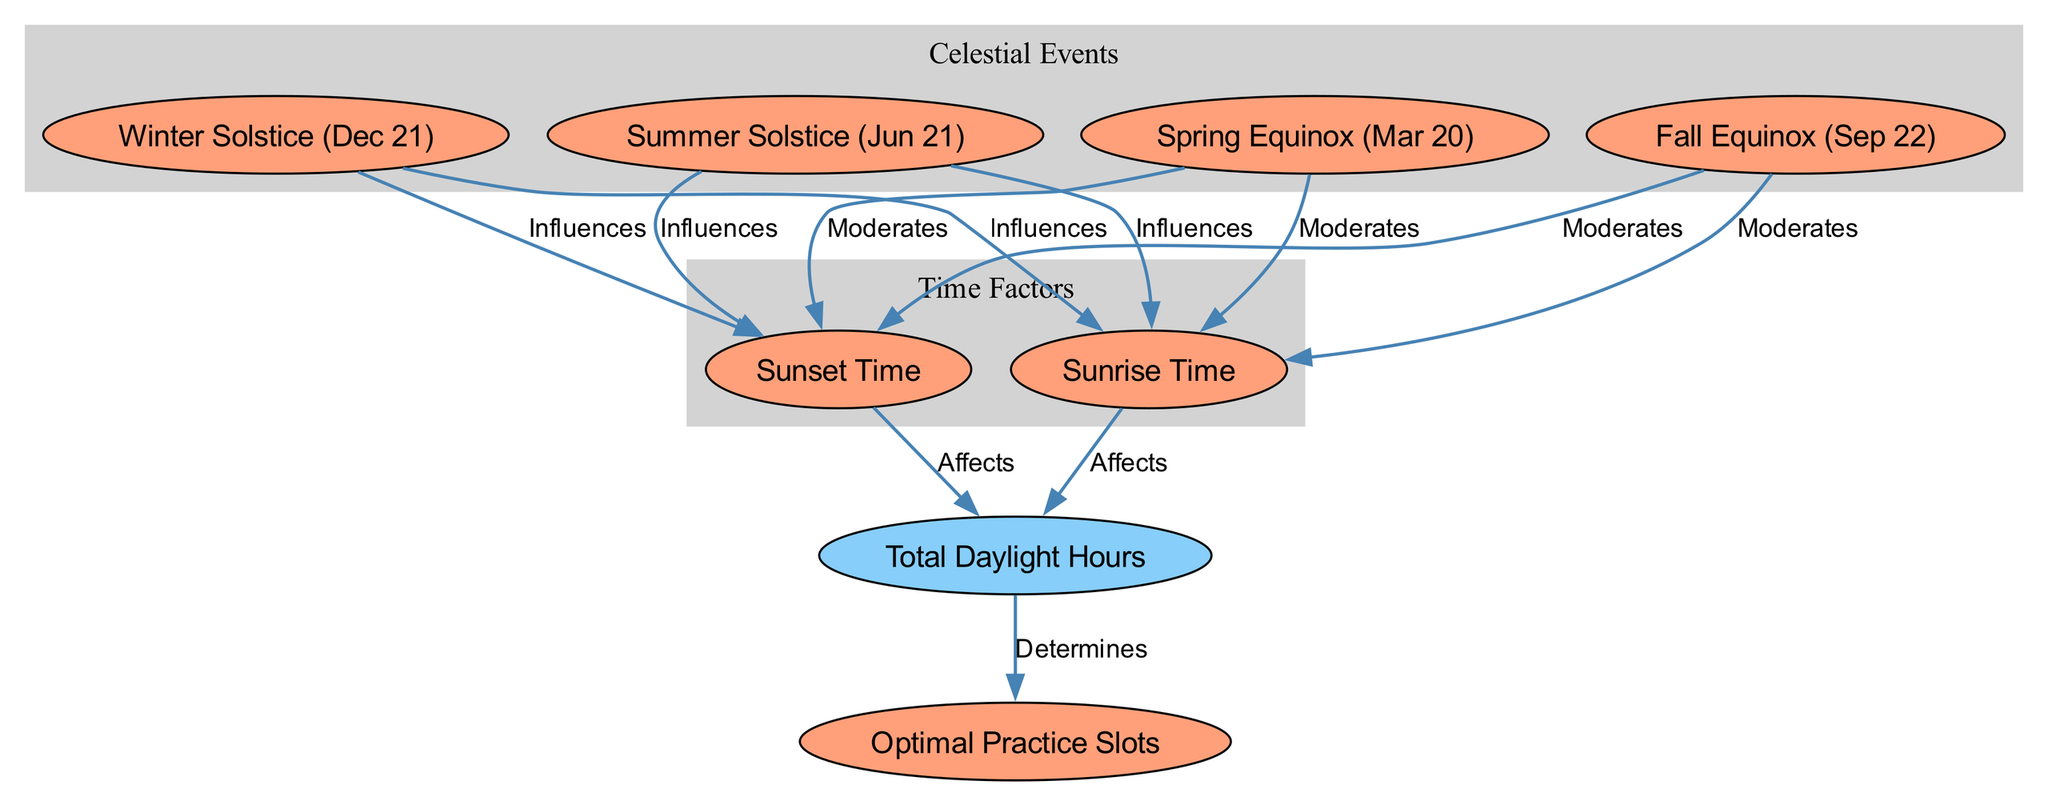What is the relationship between sunrise and daylight hours? Sunrise affects the total daylight hours according to the directed edge labeled "Affects" that connects "sunrise" to "daylightHours". This means that as the sunrise time changes, it directly influences how many daylight hours there are in a day.
Answer: Affects How many optimal practice slots are determined by daylight hours? The "Optimal Practice Slots" node is directly connected to the "Total Daylight Hours" node through an edge labeled "Determines". This indicates that the number of practice slots available is directly linked to the total hours of daylight.
Answer: Determines What season influences both sunrise and sunset times the most? The seasons that have a direct influence on both sunrise and sunset are represented by the "Winter Solstice" and "Summer Solstice". The connections labeled "Influences" indicate that these solstices impact both sunrise and sunset times.
Answer: Winter Solstice, Summer Solstice Which equinox moderates sunrise? The "Spring Equinox" and "Fall Equinox" both moderate sunrise as indicated by the edges labeled "Moderates" that connect them to the "Sunrise Time" node. This means their occurrence helps regulate when the sun rises during the year.
Answer: Spring Equinox, Fall Equinox How do daylight hours vary during the year? The daylight hours change due to the influences of the different seasons: the winter solstice leads to shorter daylight hours, while the summer solstice results in longer daylight hours. By examining the connections and understanding their seasonal impacts, it’s clear that the variation is tied to the time of year.
Answer: Variably What nodes are classified as celestial events? The nodes categorized as celestial events are the ones related to specific dates: "Winter Solstice," "Summer Solstice," "Spring Equinox," and "Fall Equinox." These nodes are distinct in that they represent significant astronomical events that don't directly calculate a time or duration.
Answer: Winter Solstice, Summer Solstice, Spring Equinox, Fall Equinox Which factors influence practice slots? The optimal practice slots are influenced by daylight hours, which in turn are affected by both sunrise and sunset times. In this flow of relationships, we first consider how sunrise and sunset lead to daylight hours, and then how these hours determine the number of available practice slots.
Answer: Sunrise, Sunset How many nodes represent time factors in this diagram? The time factors represented in the diagram are "Sunrise Time" and "Sunset Time," which are directly linked to the calculation of total daylight hours. Since there are two nodes functioning as time factors, the answer is two.
Answer: Two 